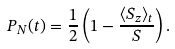<formula> <loc_0><loc_0><loc_500><loc_500>P _ { N } ( t ) = \frac { 1 } { 2 } \left ( 1 - \frac { \langle S _ { z } \rangle _ { t } } { S } \right ) .</formula> 